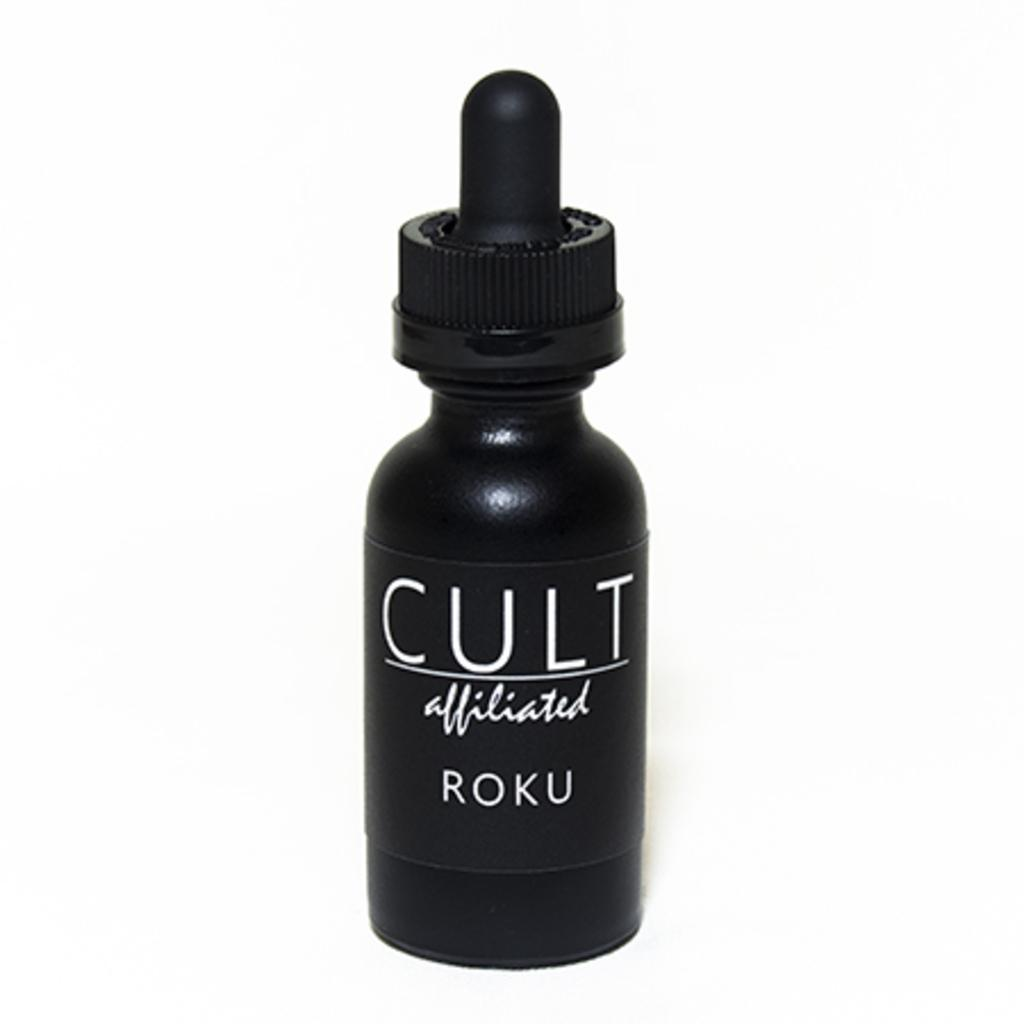<image>
Describe the image concisely. the word cult is on a black item 